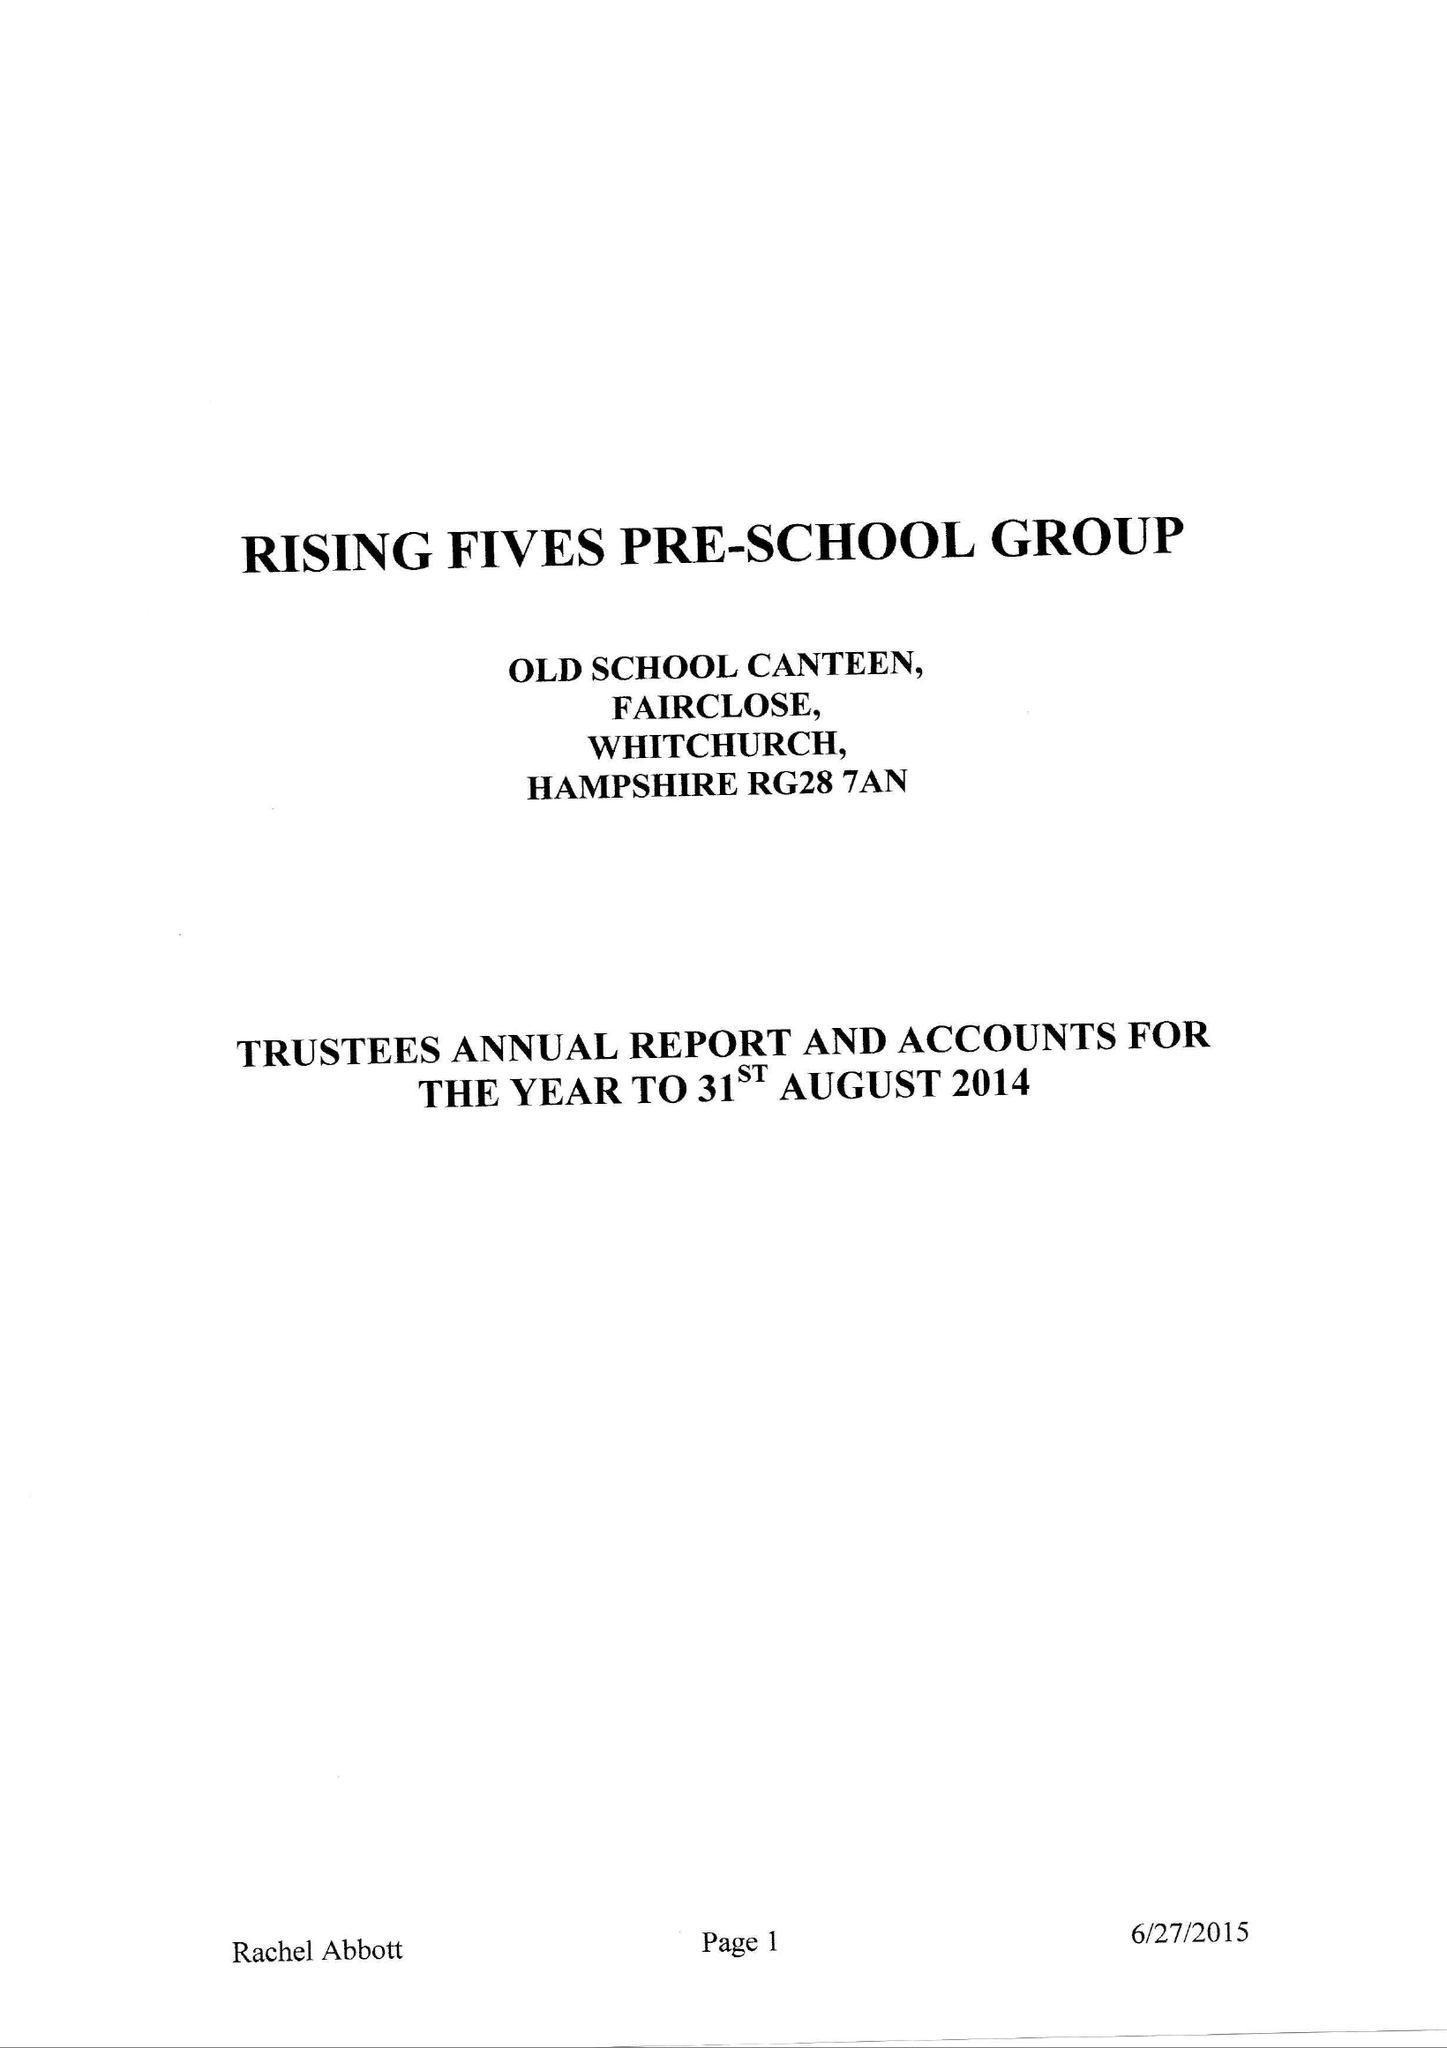What is the value for the spending_annually_in_british_pounds?
Answer the question using a single word or phrase. 114904.00 